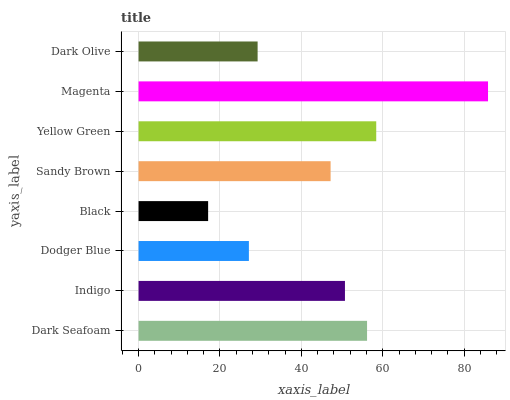Is Black the minimum?
Answer yes or no. Yes. Is Magenta the maximum?
Answer yes or no. Yes. Is Indigo the minimum?
Answer yes or no. No. Is Indigo the maximum?
Answer yes or no. No. Is Dark Seafoam greater than Indigo?
Answer yes or no. Yes. Is Indigo less than Dark Seafoam?
Answer yes or no. Yes. Is Indigo greater than Dark Seafoam?
Answer yes or no. No. Is Dark Seafoam less than Indigo?
Answer yes or no. No. Is Indigo the high median?
Answer yes or no. Yes. Is Sandy Brown the low median?
Answer yes or no. Yes. Is Black the high median?
Answer yes or no. No. Is Indigo the low median?
Answer yes or no. No. 